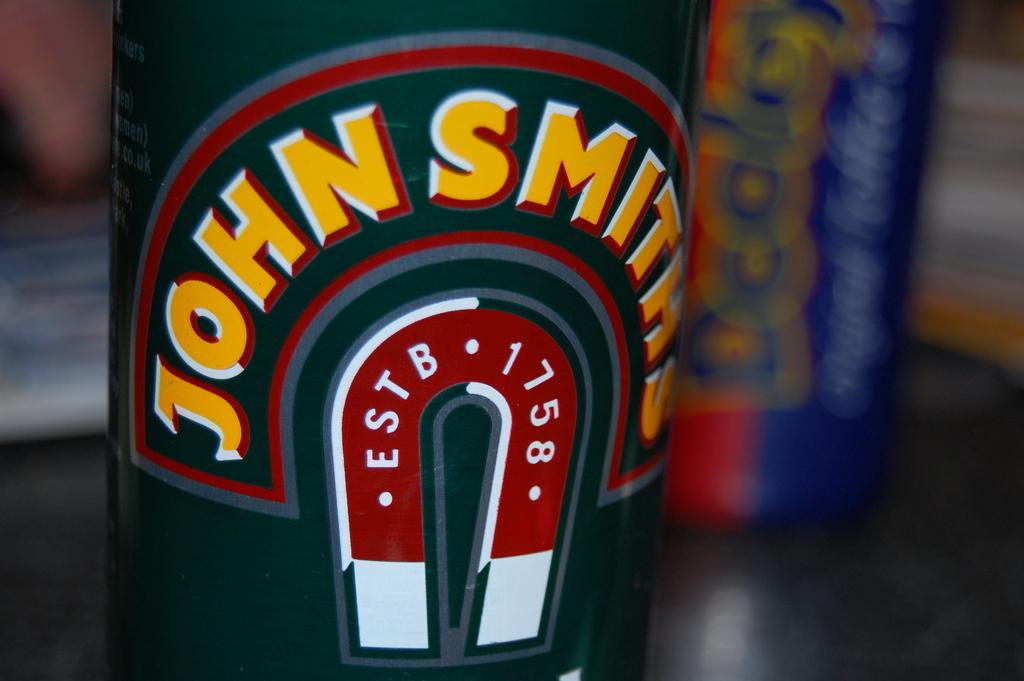<image>
Render a clear and concise summary of the photo. A can that says John Smiths with a horseshoe picture on it that says ESTB 1758 is shown. 